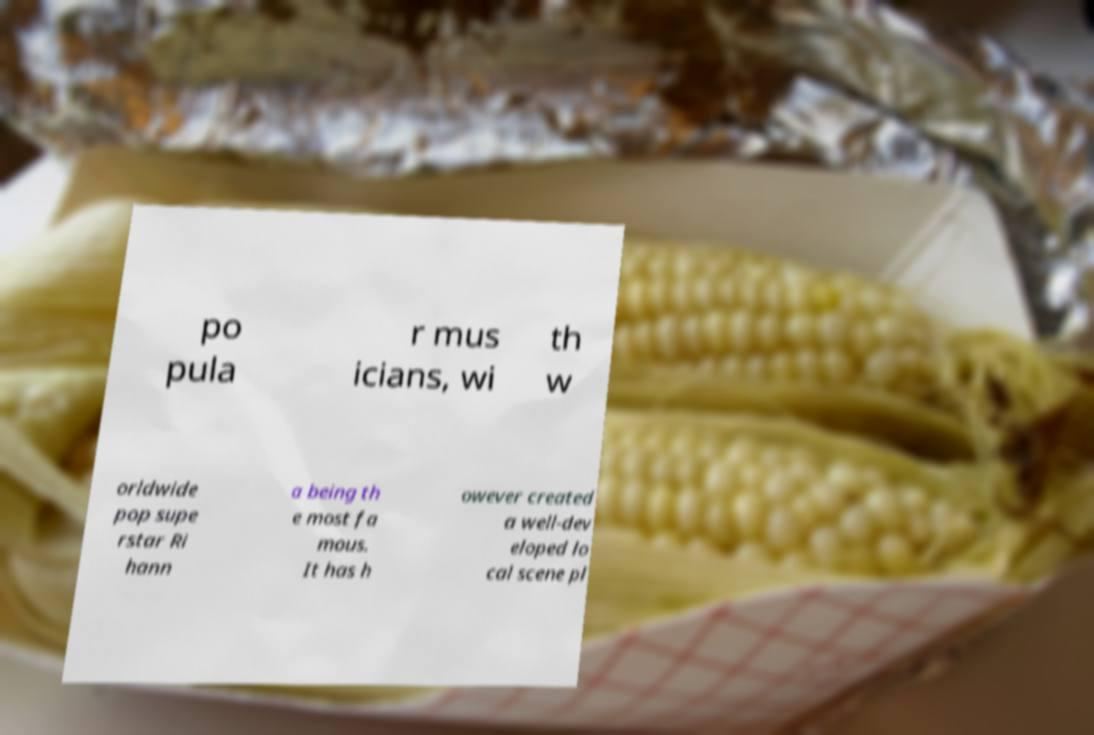Can you read and provide the text displayed in the image?This photo seems to have some interesting text. Can you extract and type it out for me? po pula r mus icians, wi th w orldwide pop supe rstar Ri hann a being th e most fa mous. It has h owever created a well-dev eloped lo cal scene pl 